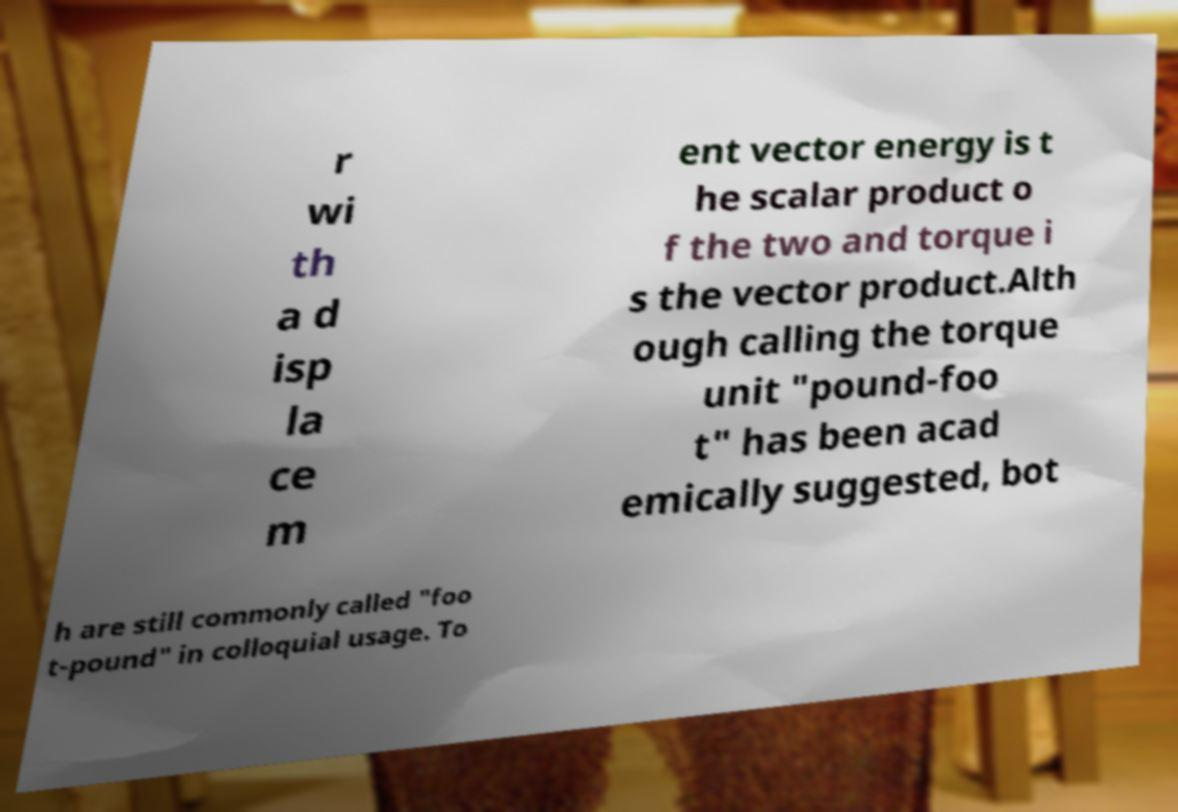For documentation purposes, I need the text within this image transcribed. Could you provide that? r wi th a d isp la ce m ent vector energy is t he scalar product o f the two and torque i s the vector product.Alth ough calling the torque unit "pound-foo t" has been acad emically suggested, bot h are still commonly called "foo t-pound" in colloquial usage. To 